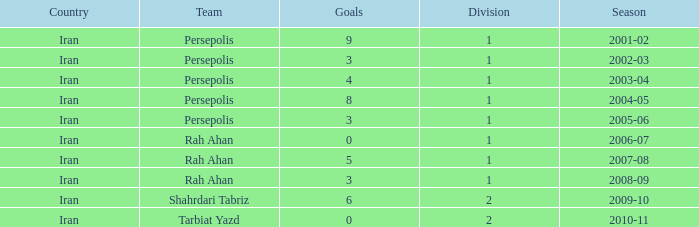What is the sum of Goals, when Season is "2005-06", and when Division is less than 1? None. 